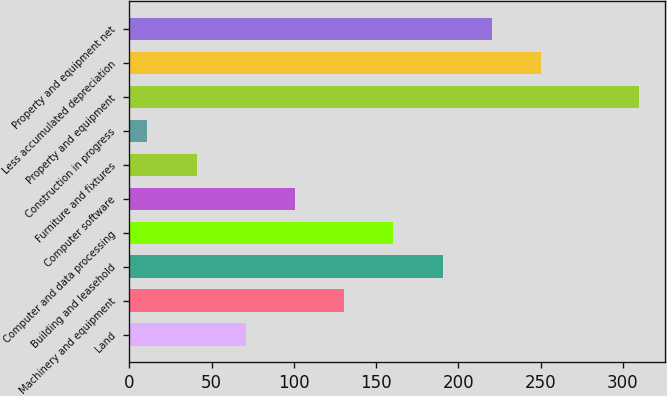Convert chart to OTSL. <chart><loc_0><loc_0><loc_500><loc_500><bar_chart><fcel>Land<fcel>Machinery and equipment<fcel>Building and leasehold<fcel>Computer and data processing<fcel>Computer software<fcel>Furniture and fixtures<fcel>Construction in progress<fcel>Property and equipment<fcel>Less accumulated depreciation<fcel>Property and equipment net<nl><fcel>70.74<fcel>130.58<fcel>190.42<fcel>160.5<fcel>100.66<fcel>40.82<fcel>10.9<fcel>310.1<fcel>250.26<fcel>220.34<nl></chart> 